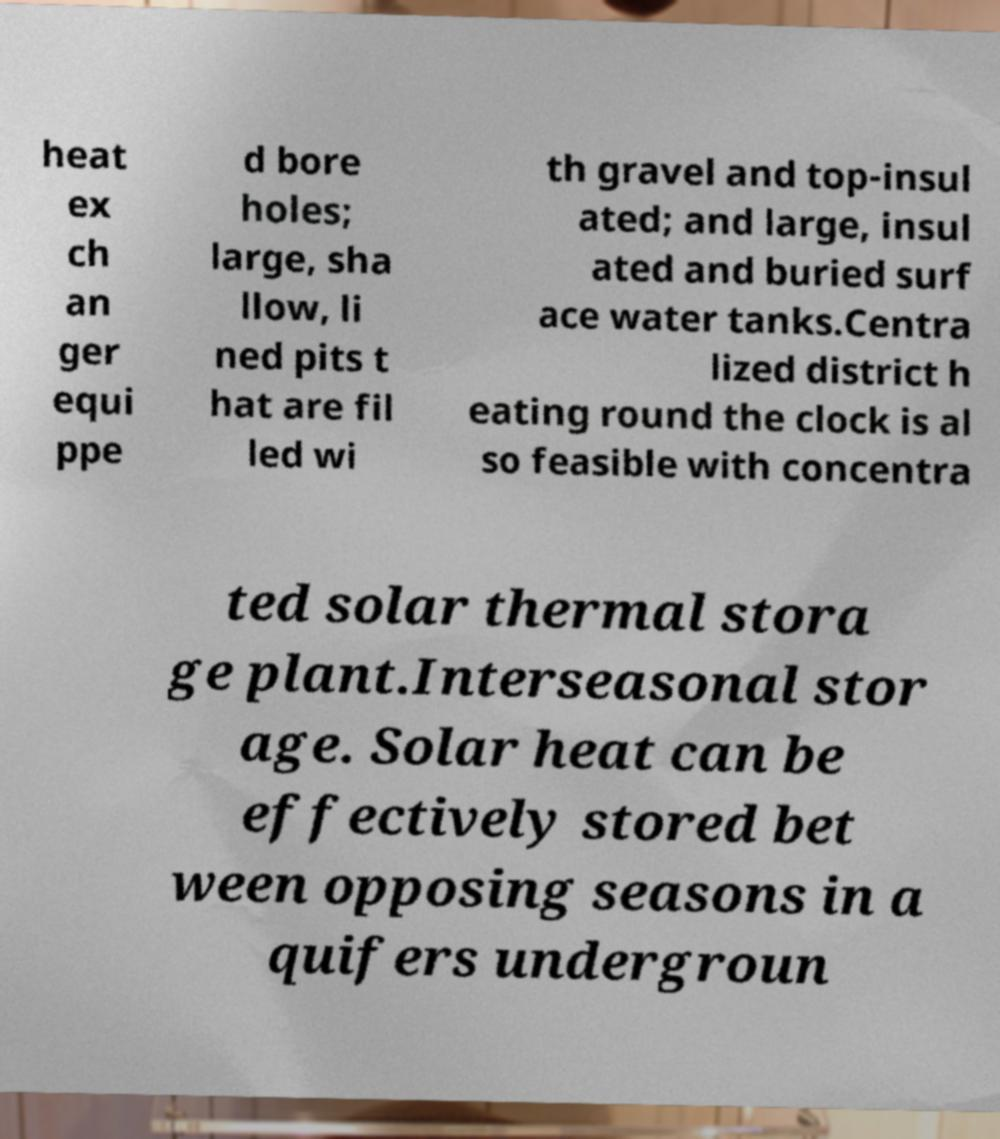I need the written content from this picture converted into text. Can you do that? heat ex ch an ger equi ppe d bore holes; large, sha llow, li ned pits t hat are fil led wi th gravel and top-insul ated; and large, insul ated and buried surf ace water tanks.Centra lized district h eating round the clock is al so feasible with concentra ted solar thermal stora ge plant.Interseasonal stor age. Solar heat can be effectively stored bet ween opposing seasons in a quifers undergroun 